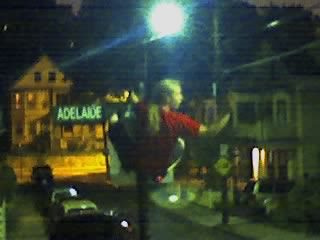What time of day does this image seem to portray? The image appears to capture a scene during the evening or night, as indicated by the streetlights being on and the ambient darkness. Can you describe the weather conditions in the image? While specific weather conditions are not clearly visible, the overall darkness and streetlight glow might suggest it is a clear night. There's no visible rain or snow, and no reflections on wet surfaces that would imply recent precipitation. 